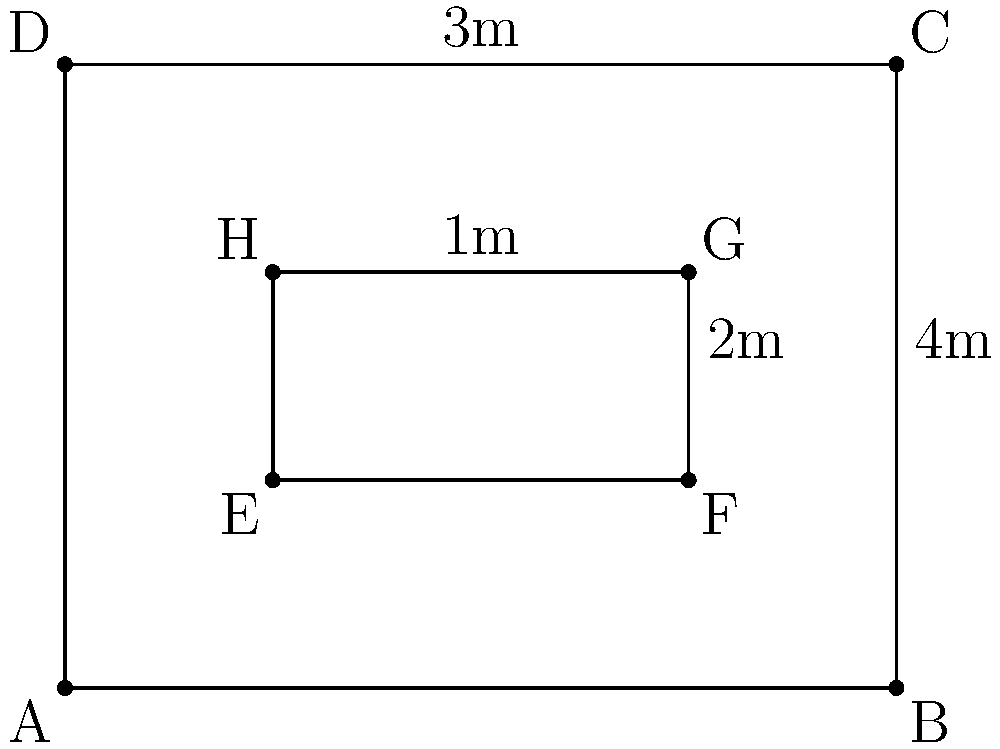You are preparing to wallpaper a room with an unusual layout. The room has a rectangular shape with dimensions of 4m by 3m, but there's a central rectangular area that doesn't need wallpapering (perhaps due to a built-in bookshelf or window). This central area measures 2m by 1m. Calculate the total surface area that needs to be wallpapered. Additionally, if each roll of wallpaper covers 5 square meters, how many rolls will you need to complete the job, assuming no waste? Let's approach this step-by-step:

1. Calculate the total area of the room:
   $A_{total} = 4m \times 3m = 12m^2$

2. Calculate the area of the central rectangle that doesn't need wallpapering:
   $A_{center} = 2m \times 1m = 2m^2$

3. Calculate the area to be wallpapered by subtracting the central area from the total area:
   $A_{wallpaper} = A_{total} - A_{center} = 12m^2 - 2m^2 = 10m^2$

4. To determine the number of rolls needed, divide the area to be wallpapered by the coverage of each roll:
   $\text{Number of rolls} = \frac{A_{wallpaper}}{\text{Coverage per roll}} = \frac{10m^2}{5m^2/\text{roll}} = 2 \text{ rolls}$

Therefore, you will need to wallpaper 10 square meters and use 2 rolls of wallpaper.
Answer: 10m², 2 rolls 